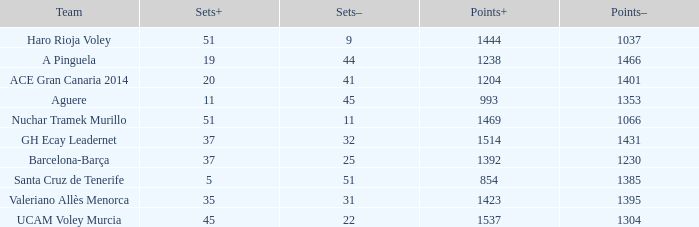What is the total number of Points- when the Sets- is larger than 51? 0.0. 